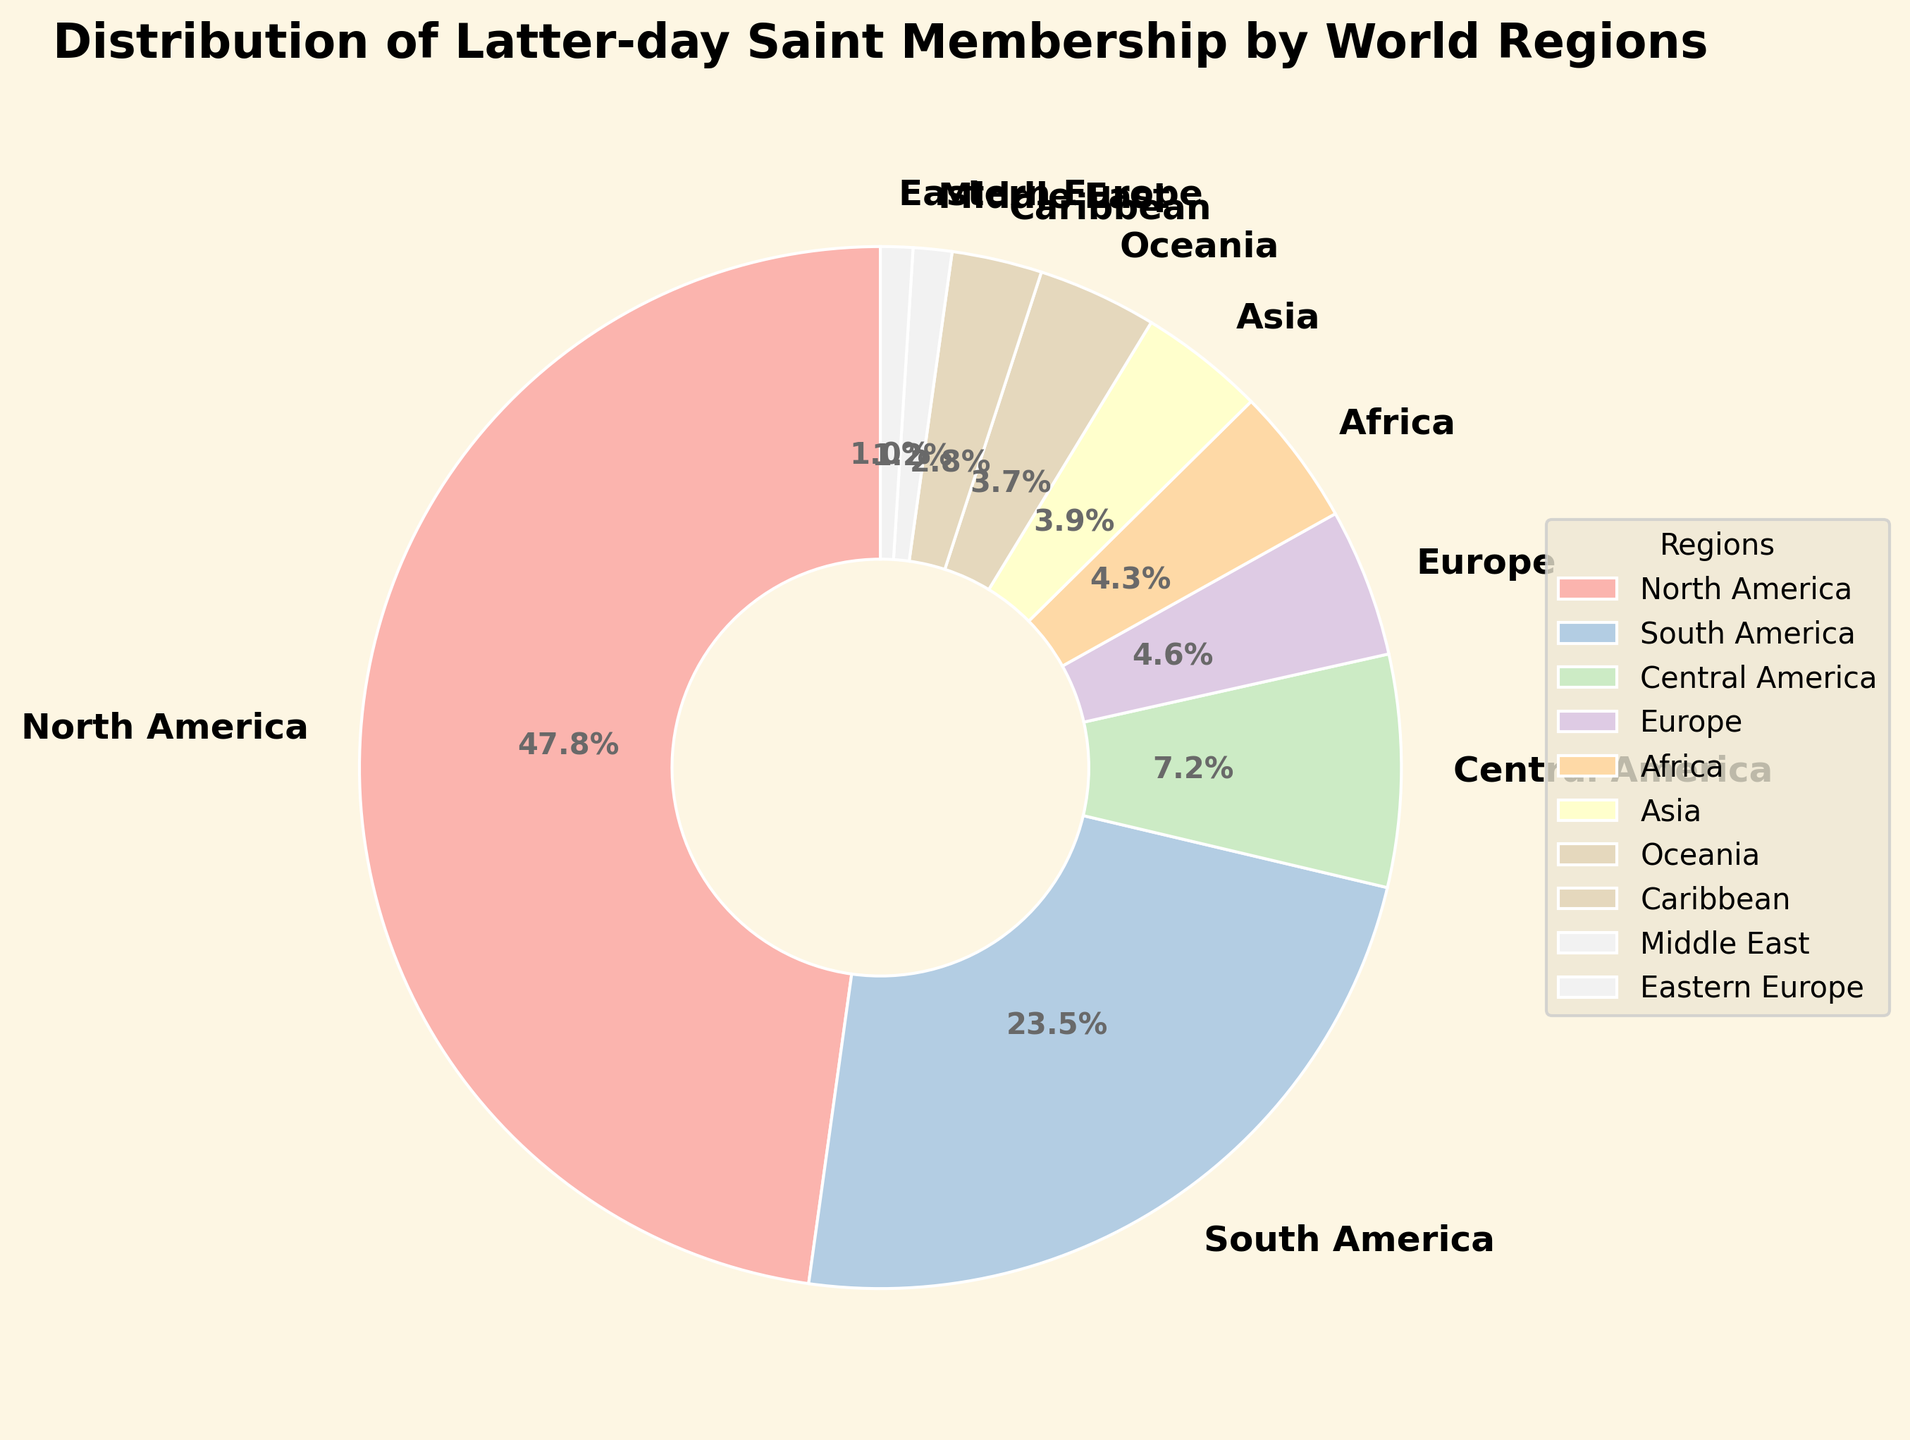What percentage of Latter-day Saint members are in North America compared to Asia? North America has 47.8% of the membership, while Asia has 3.9%. To compare, subtract Asia's percentage from North America's percentage: 47.8% - 3.9% = 43.9%.
Answer: 43.9% Which region has the smallest percentage of Latter-day Saint members? By observing the pie chart, Eastern Europe has the smallest slice which corresponds to 1.0%.
Answer: Eastern Europe What is the combined percentage of Latter-day Saint members from South America and Central America? South America has 23.5% and Central America has 7.2%. Adding these percentages together: 23.5% + 7.2% = 30.7%.
Answer: 30.7% Which region has a higher percentage of Latter-day Saint members, the Caribbean or Europe? The Caribbean has 2.8% and Europe has 4.6%, so Europe has a higher percentage.
Answer: Europe What percentage of Latter-day Saint members are located in the Middle East? The pie chart shows that the Middle East has 1.2% of members.
Answer: 1.2% How many regions have a percentage greater than 4%? North America, South America, Central America, and Europe have percentages greater than 4%. This results in 4 regions.
Answer: 4 Which regions have a combined percentage of exactly 8.3%? By observing the pie chart, Asia has 3.9% and Eastern Europe has 1.0%, Africa has 4.3%. Adding these (3.9% + 4.3% + 1.0% = 9.2%).
Answer: None What is the difference in membership percentage between Oceania and Africa? Africa has 4.3%, and Oceania has 3.7%, so the difference is 4.3% - 3.7% = 0.6%.
Answer: 0.6% Which two regions have the closest membership percentages to each other? Africa (4.3%) and Europe (4.6%) have the closest percentages, with a difference of 0.3%.
Answer: Africa and Europe 